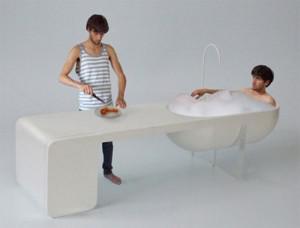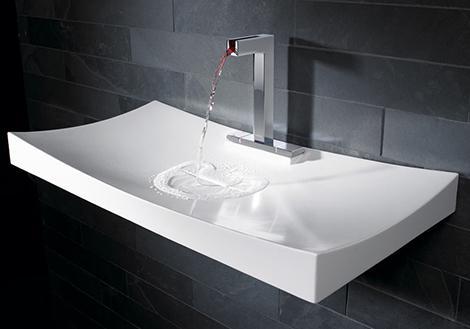The first image is the image on the left, the second image is the image on the right. Evaluate the accuracy of this statement regarding the images: "One sink is a white squiggle and one sink is hollowed out from a white rectangular block.". Is it true? Answer yes or no. No. The first image is the image on the left, the second image is the image on the right. Analyze the images presented: Is the assertion "The sink in the image on the left curves down toward the floor." valid? Answer yes or no. No. 